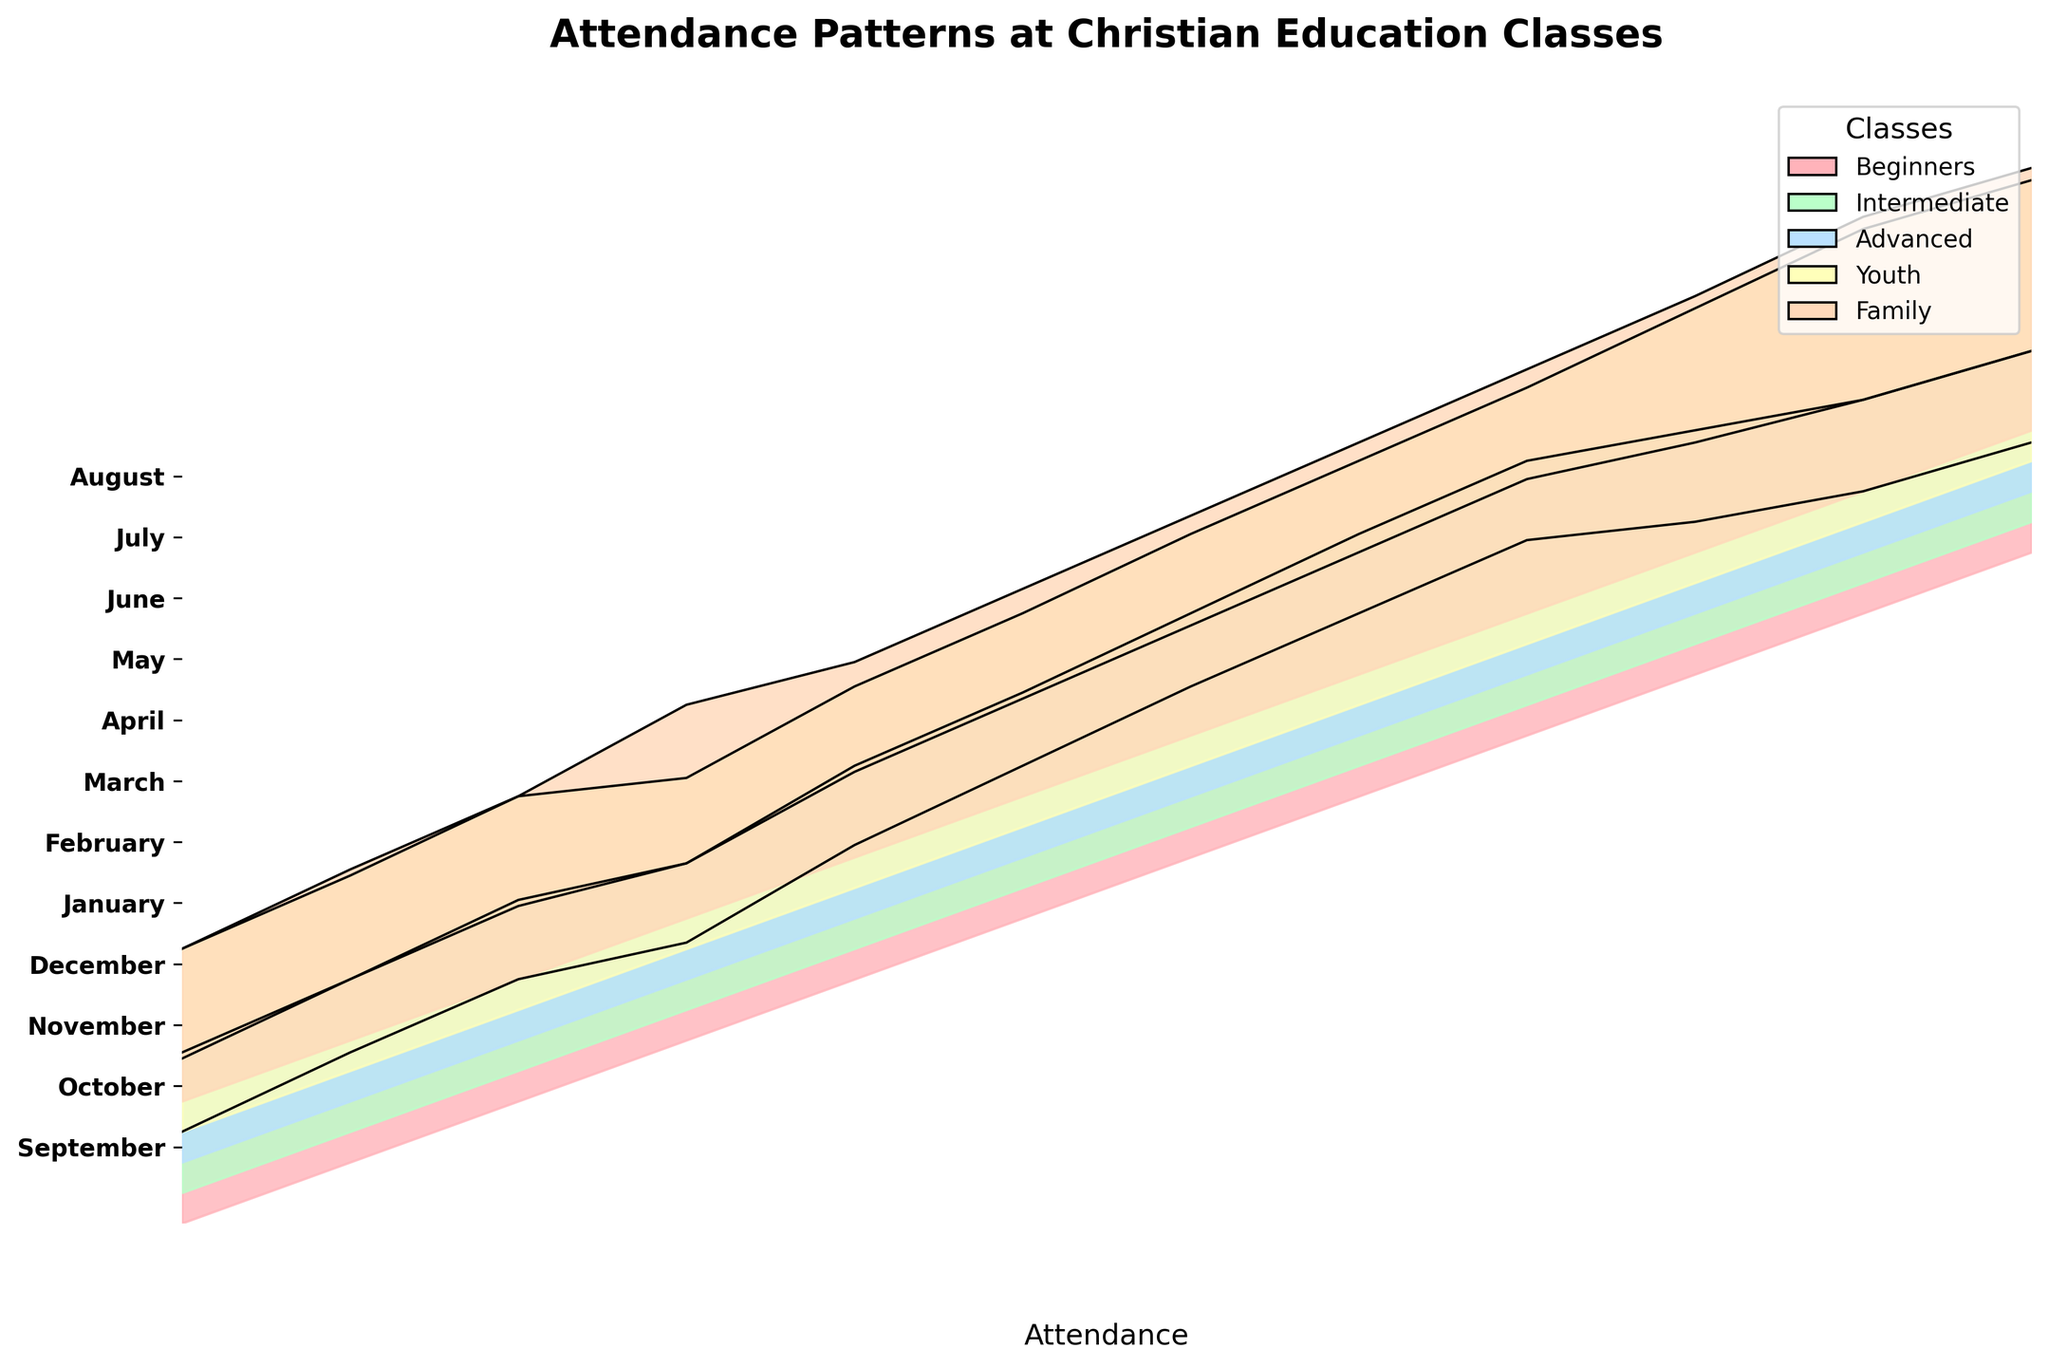What is the title of the figure? The title of the figure is usually displayed prominently at the top of the graph. In this case, it is specified in the code that generates the chart.
Answer: Attendance Patterns at Christian Education Classes Which class has the highest attendance in March? To determine which class has the highest attendance, look for the highest peak in March. According to the data, it is the Youth class.
Answer: Youth How many classes are depicted in the graph? There are five different categories of classes referenced in the dataset, which are visualized in the graph. You can also observe the legend to count the number of classes.
Answer: Five During which month does the Family class reach its peak attendance? Find the highest segment representing the Family class. According to the data, the Family class peaks in July.
Answer: July Compare the attendance of Beginners and Advanced classes in April. Which one is higher? To compare, look at the heights of the segments for the Beginners and Advanced classes in April. According to the data, the attendance for Beginners is 30, and for Advanced is 30 as well.
Answer: Both are equal What is the trend in attendance for the Intermediate class from September to December? To find the trend, observe the pattern of the Intermediate class from September to December. The attendance increases from September to November and then slightly decreases in December.
Answer: Increases, then decreases Which class shows the most consistent attendance throughout the year? Consistency can be identified by finding the class with the least variation in peaks and troughs across all months. Observing the plot, the Advanced class shows relatively consistent attendance.
Answer: Advanced Between which months does the Youth class show the largest increase in attendance? To find the largest increase, compare the heights of the Youth class segments from month to month. The largest jump is from June to July.
Answer: June to July Calculate the average attendance for the Family class across the entire year. Sum the attendance figures for the Family class from September to August and divide by the total number of months. (25+28+30+35+32+34+36+38+40+42+45+43)/12 = 36.25
Answer: 36.25 